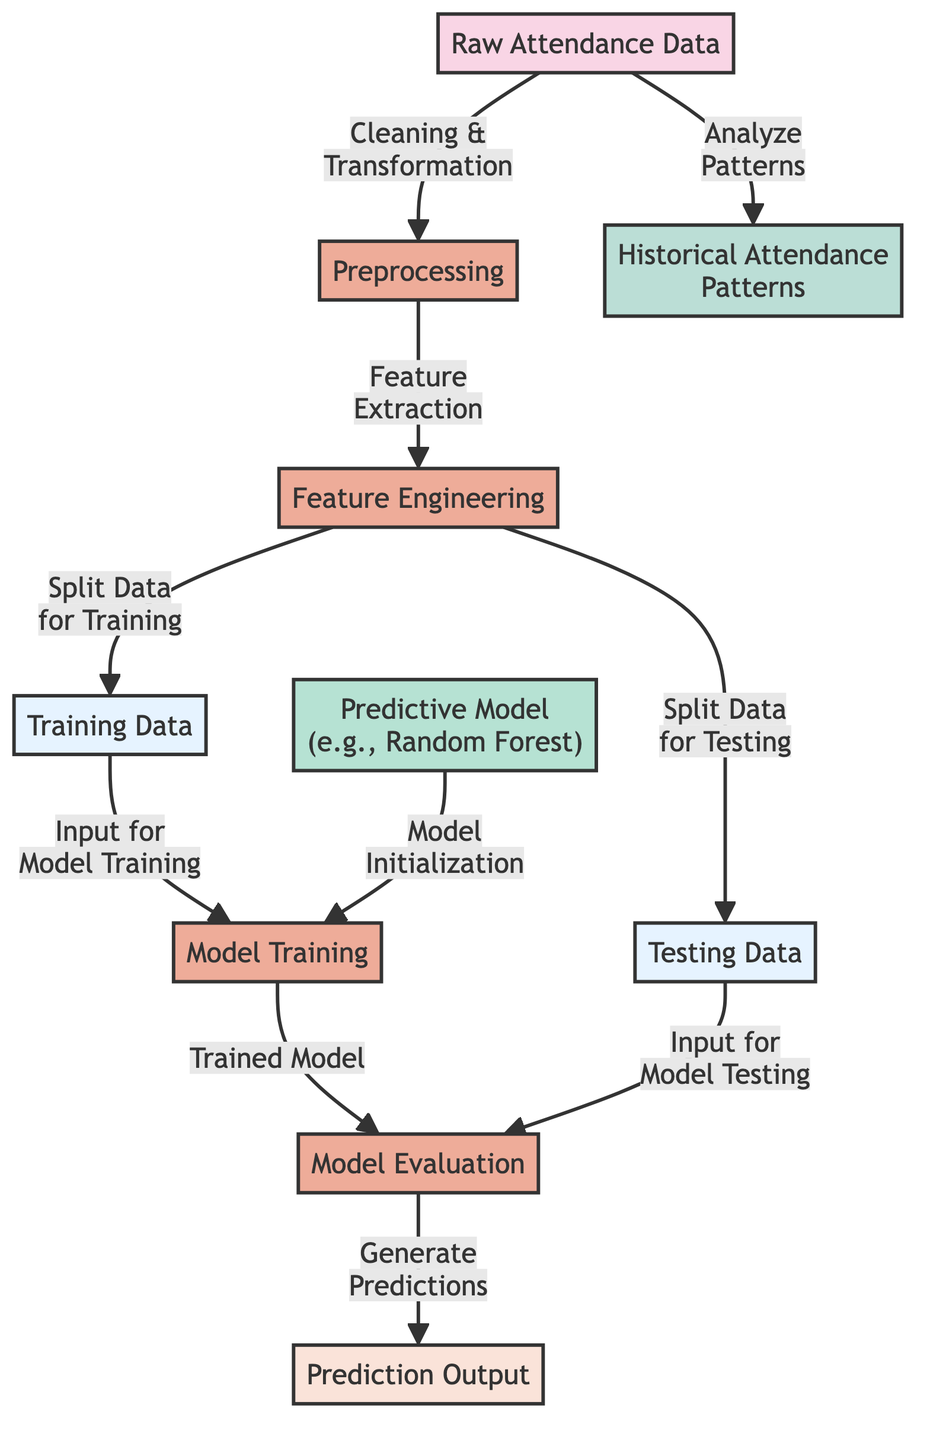What is the main data input for this diagram? The diagram begins with the node labeled "Raw Attendance Data", indicating that this is the primary input for the subsequent processes.
Answer: Raw Attendance Data How many processes are shown in the diagram? By counting the nodes categorized with the "process" class, we find there are four processes shown: Preprocessing, Feature Engineering, Model Training, and Model Evaluation.
Answer: Four What type of predictive model is mentioned? The diagram specifically mentions “Random Forest” as an example of the predictive model being used in this analysis.
Answer: Random Forest What is created from the "Training Data"? The diagram shows that the "Training Data" is used to input for "Model Training", indicating that it's essential for training the model.
Answer: Model Training What insights can be derived from the "Raw Attendance Data"? The diagram indicates that historical attendance patterns can be analyzed from "Raw Attendance Data", illustrating a direct relationship.
Answer: Historical Attendance Patterns What is the output of the prediction process? The prediction process generates output specified as "Prediction Output", which represents the final results from the model after predictions are made.
Answer: Prediction Output Which node indicates a split in the dataset? The diagram shows that "Split Data for Training" and "Split Data for Testing" are the nodes indicating the separation of the dataset into two parts.
Answer: Split Data for Training and Split Data for Testing What follows the "Model Evaluation" node in the process? According to the flow in the diagram, after "Model Evaluation", the next step is to generate predictions from the trained model.
Answer: Generate Predictions Which node reveals the analysis performed on the data? The "Analyze Patterns" link from the "Raw Attendance Data" indicates which analysis is performed on the data to uncover insights.
Answer: Analyze Patterns 